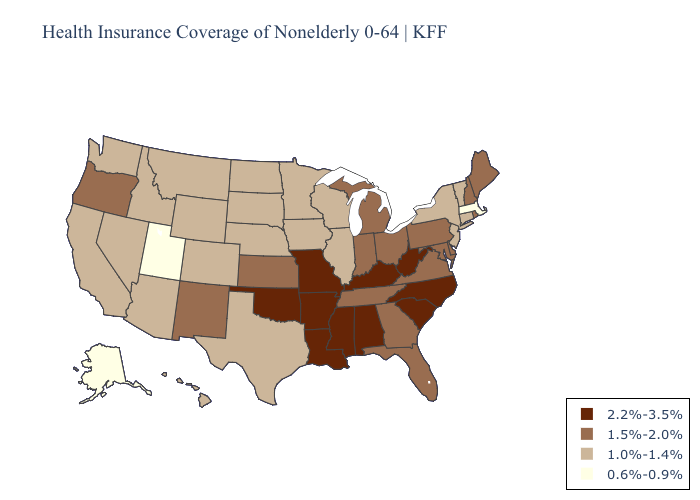Name the states that have a value in the range 1.5%-2.0%?
Short answer required. Delaware, Florida, Georgia, Indiana, Kansas, Maine, Maryland, Michigan, New Hampshire, New Mexico, Ohio, Oregon, Pennsylvania, Rhode Island, Tennessee, Virginia. Does New York have the highest value in the Northeast?
Give a very brief answer. No. Among the states that border Massachusetts , which have the lowest value?
Write a very short answer. Connecticut, New York, Vermont. What is the value of Wyoming?
Keep it brief. 1.0%-1.4%. Does Mississippi have the lowest value in the USA?
Short answer required. No. Does North Dakota have the lowest value in the USA?
Write a very short answer. No. Among the states that border Arizona , which have the lowest value?
Concise answer only. Utah. What is the highest value in the West ?
Be succinct. 1.5%-2.0%. What is the lowest value in states that border Delaware?
Write a very short answer. 1.0%-1.4%. How many symbols are there in the legend?
Be succinct. 4. Does Oklahoma have the highest value in the South?
Write a very short answer. Yes. Name the states that have a value in the range 2.2%-3.5%?
Write a very short answer. Alabama, Arkansas, Kentucky, Louisiana, Mississippi, Missouri, North Carolina, Oklahoma, South Carolina, West Virginia. Among the states that border Kentucky , which have the highest value?
Give a very brief answer. Missouri, West Virginia. Name the states that have a value in the range 1.0%-1.4%?
Short answer required. Arizona, California, Colorado, Connecticut, Hawaii, Idaho, Illinois, Iowa, Minnesota, Montana, Nebraska, Nevada, New Jersey, New York, North Dakota, South Dakota, Texas, Vermont, Washington, Wisconsin, Wyoming. 